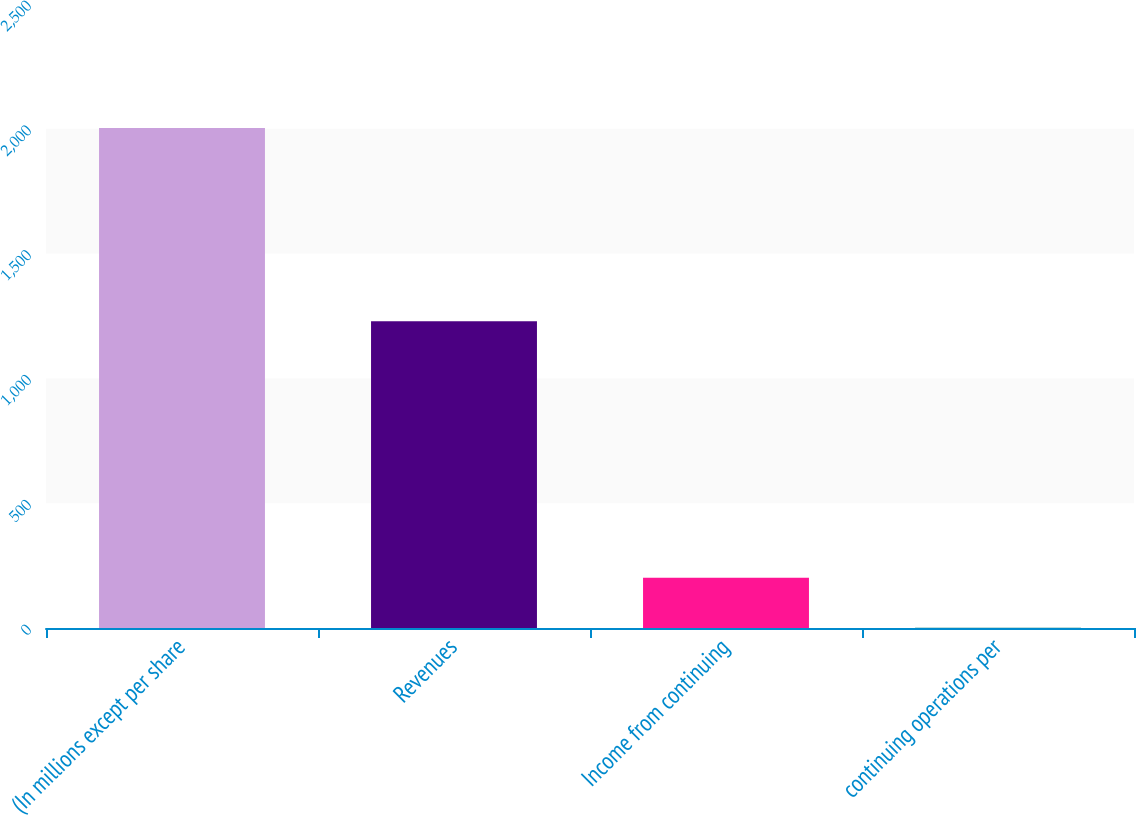<chart> <loc_0><loc_0><loc_500><loc_500><bar_chart><fcel>(In millions except per share<fcel>Revenues<fcel>Income from continuing<fcel>continuing operations per<nl><fcel>2003<fcel>1228.6<fcel>201.47<fcel>1.3<nl></chart> 